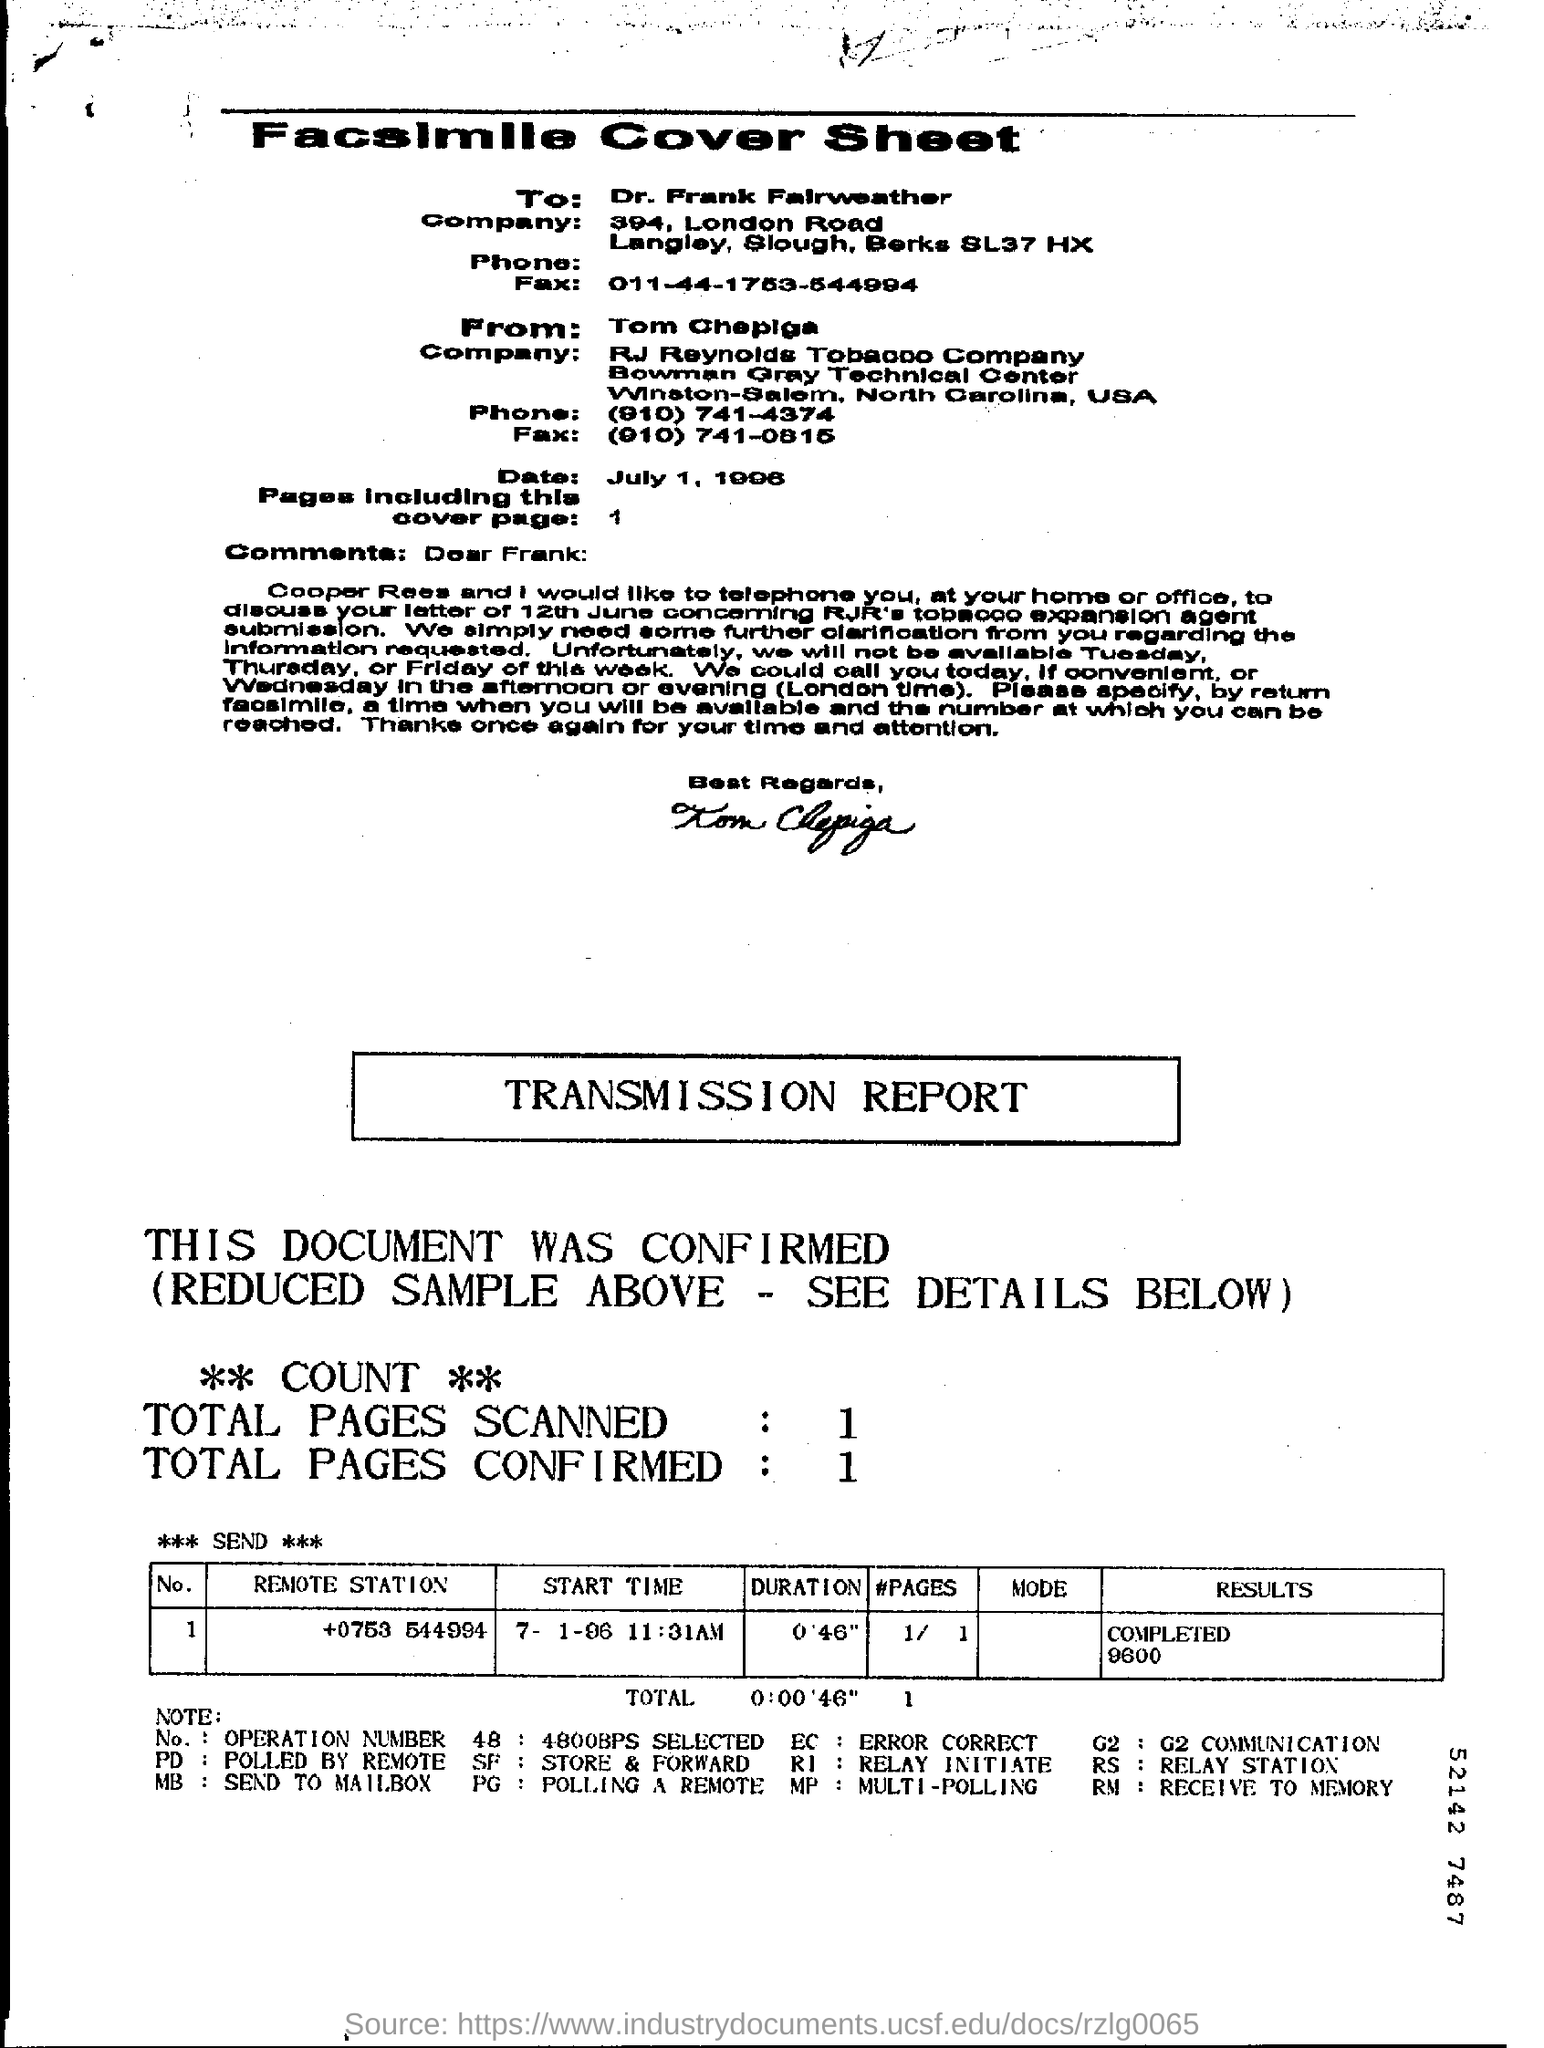Whose name is given in "To" field in the cover sheet?
Provide a succinct answer. Dr. Frank Fairweather. What is the date mentioned in the cover sheet
Your answer should be very brief. July 1, 1996. How many pages are there including this cover page ?
Provide a succinct answer. 1. How many total pages are scanned in the transmission report ?
Your response must be concise. 1. How many total pages are confirmed in the transmission report ?
Your answer should be compact. 1. What is the start time mentioned in the transmission report ?
Your answer should be very brief. 7- 1-96   11:31 am. What is the duration mentioned in the transmission report ?
Keep it short and to the point. 0'46". What is the result given in the transmission report ?
Provide a short and direct response. Completed 9600. Who has written this facsimile cover sheet ?
Make the answer very short. Tom chepiga. 